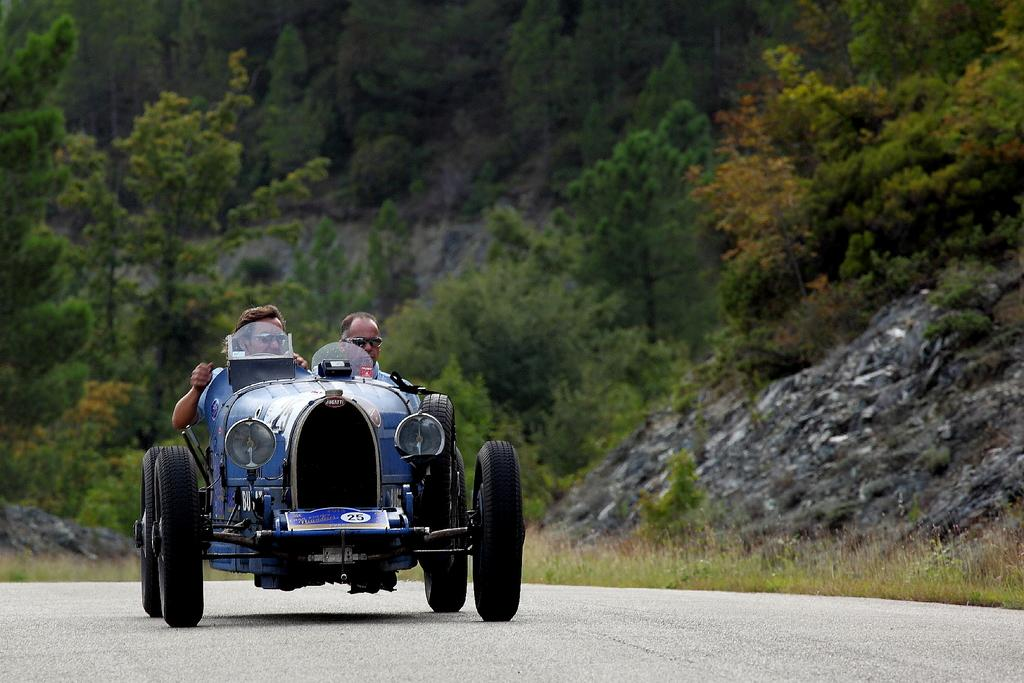What is the main feature of the image? There is a road in the image. What can be seen on the road? There is a vehicle on the road. Who is on the vehicle? Two people are sitting on the vehicle. What are the people wearing? The people are wearing goggles. What is present near the road? There is a rock on the side of the road. What can be seen in the distance in the image? There are trees in the background of the image. What word is written on the side of the vehicle? There is no word written on the side of the vehicle in the image. What scale is used to measure the distance between the trees and the road? There is no scale present in the image to measure the distance between the trees and the road. 